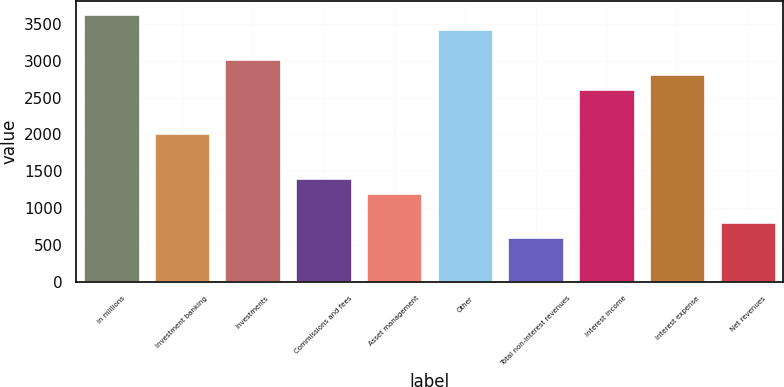<chart> <loc_0><loc_0><loc_500><loc_500><bar_chart><fcel>in millions<fcel>Investment banking<fcel>Investments<fcel>Commissions and fees<fcel>Asset management<fcel>Other<fcel>Total non-interest revenues<fcel>Interest income<fcel>Interest expense<fcel>Net revenues<nl><fcel>3628<fcel>2016<fcel>3023.5<fcel>1411.5<fcel>1210<fcel>3426.5<fcel>605.5<fcel>2620.5<fcel>2822<fcel>807<nl></chart> 